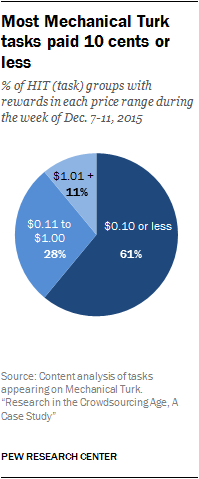Specify some key components in this picture. The largest segment was divided by the smallest segment, and the result was not greater than the smallest segment. The color of the largest segment is navy blue. 